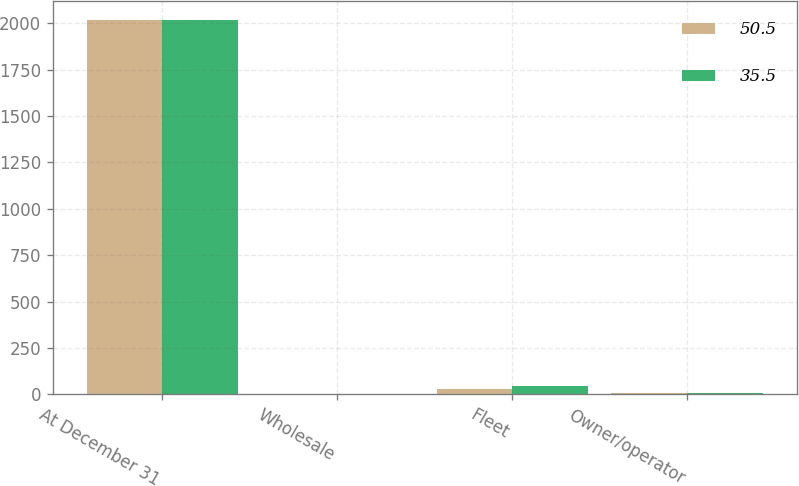Convert chart to OTSL. <chart><loc_0><loc_0><loc_500><loc_500><stacked_bar_chart><ecel><fcel>At December 31<fcel>Wholesale<fcel>Fleet<fcel>Owner/operator<nl><fcel>50.5<fcel>2018<fcel>0.1<fcel>27.5<fcel>7.9<nl><fcel>35.5<fcel>2017<fcel>0.1<fcel>44.4<fcel>6<nl></chart> 